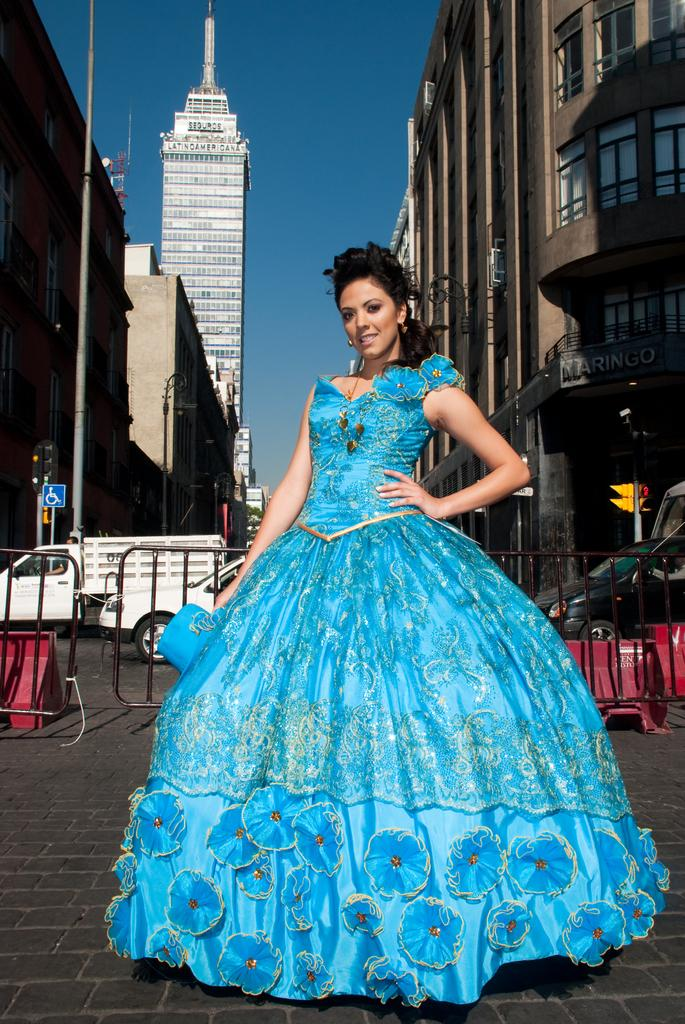What is the woman doing in the image? The woman is standing on the road in the image. What can be seen in the image related to cooking or food preparation? There are grills visible in the image. What type of objects are present in the image to control traffic? Barrier poles, traffic poles, and traffic signals are present in the image to control traffic. What type of structures are visible in the image? Buildings are visible in the image. What type of lighting is present in the image? Street lights are in the image. What type of guitar is the woman playing in the image? There is no guitar present in the image; the woman is standing on the road. What is the woman writing on the sign board in the image? There is no writing activity or sign board visible in the image. 